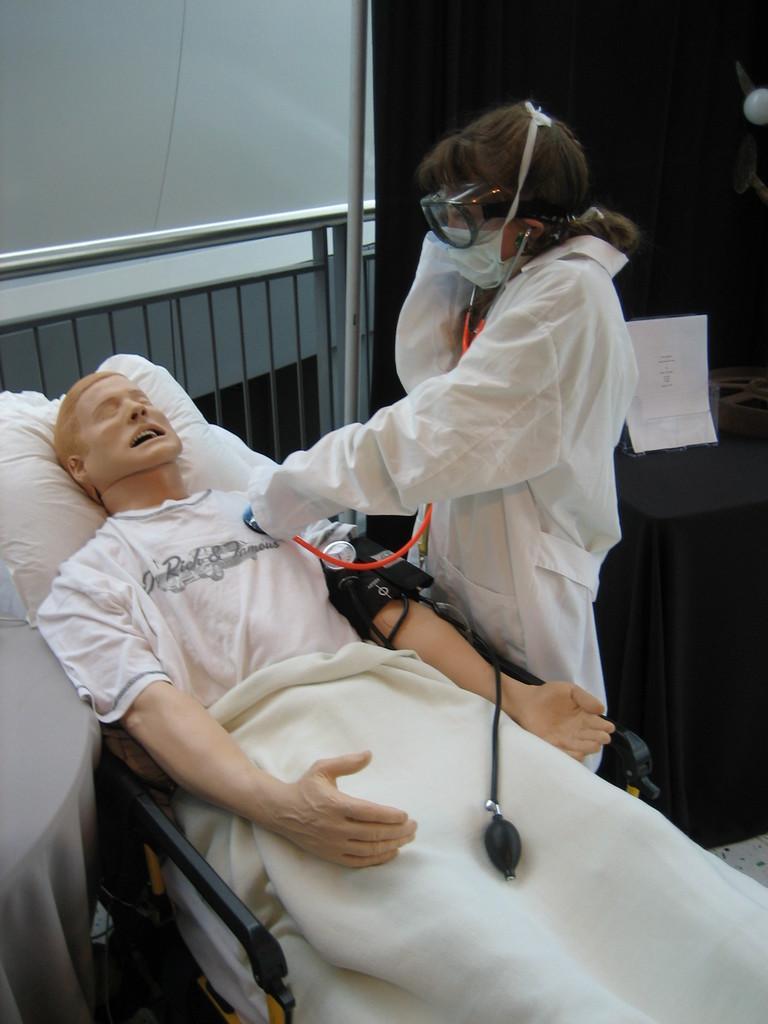Could you give a brief overview of what you see in this image? In this image I can see a toy which is cream in color wearing white colored dress is laying on the bed. I can see a person wearing white colored dress is standing and holding a stethoscope in her hand. I can see a black colored curtain, a paper, the railing and the wall in the background. 